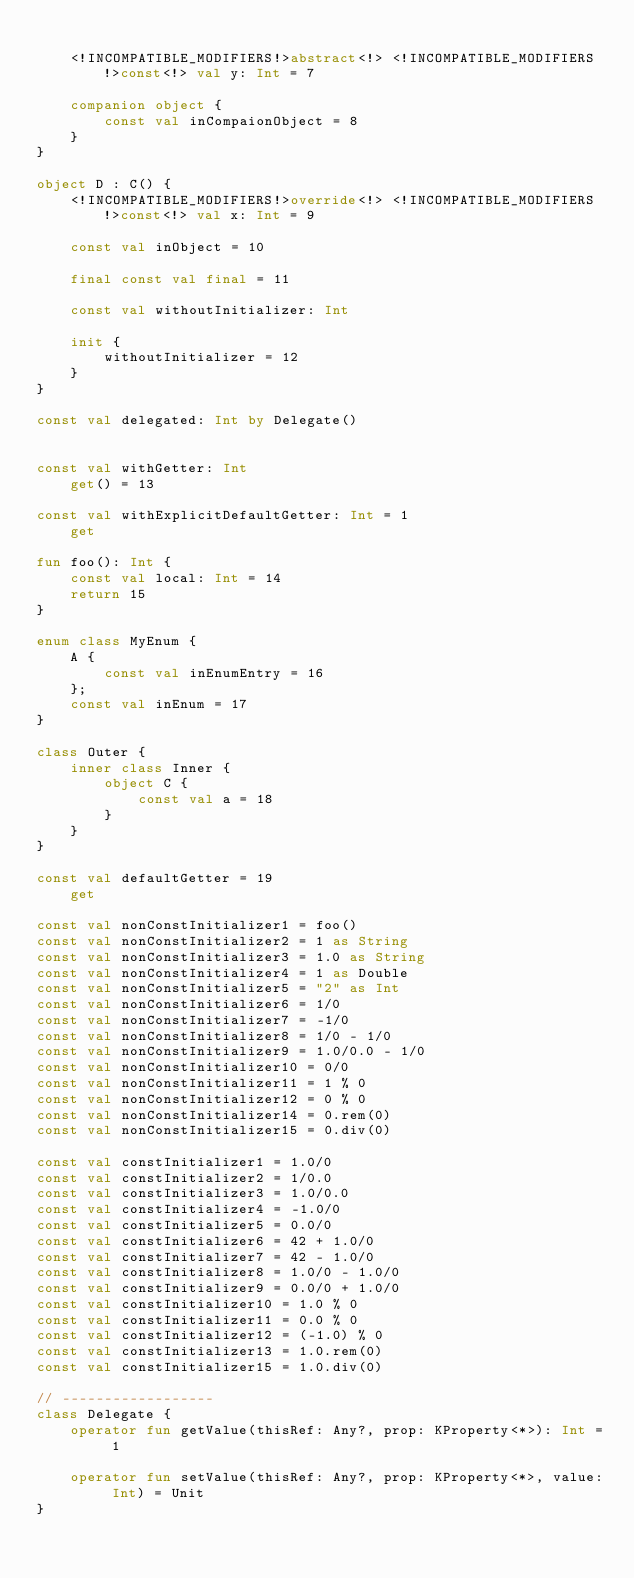<code> <loc_0><loc_0><loc_500><loc_500><_Kotlin_>
    <!INCOMPATIBLE_MODIFIERS!>abstract<!> <!INCOMPATIBLE_MODIFIERS!>const<!> val y: Int = 7

    companion object {
        const val inCompaionObject = 8
    }
}

object D : C() {
    <!INCOMPATIBLE_MODIFIERS!>override<!> <!INCOMPATIBLE_MODIFIERS!>const<!> val x: Int = 9

    const val inObject = 10

    final const val final = 11

    const val withoutInitializer: Int

    init {
        withoutInitializer = 12
    }
}

const val delegated: Int by Delegate()


const val withGetter: Int
    get() = 13

const val withExplicitDefaultGetter: Int = 1
    get

fun foo(): Int {
    const val local: Int = 14
    return 15
}

enum class MyEnum {
    A {
        const val inEnumEntry = 16
    };
    const val inEnum = 17
}

class Outer {
    inner class Inner {
        object C {
            const val a = 18
        }
    }
}

const val defaultGetter = 19
    get

const val nonConstInitializer1 = foo()
const val nonConstInitializer2 = 1 as String
const val nonConstInitializer3 = 1.0 as String
const val nonConstInitializer4 = 1 as Double
const val nonConstInitializer5 = "2" as Int
const val nonConstInitializer6 = 1/0
const val nonConstInitializer7 = -1/0
const val nonConstInitializer8 = 1/0 - 1/0
const val nonConstInitializer9 = 1.0/0.0 - 1/0
const val nonConstInitializer10 = 0/0
const val nonConstInitializer11 = 1 % 0
const val nonConstInitializer12 = 0 % 0
const val nonConstInitializer14 = 0.rem(0)
const val nonConstInitializer15 = 0.div(0)

const val constInitializer1 = 1.0/0
const val constInitializer2 = 1/0.0
const val constInitializer3 = 1.0/0.0
const val constInitializer4 = -1.0/0
const val constInitializer5 = 0.0/0
const val constInitializer6 = 42 + 1.0/0
const val constInitializer7 = 42 - 1.0/0
const val constInitializer8 = 1.0/0 - 1.0/0
const val constInitializer9 = 0.0/0 + 1.0/0
const val constInitializer10 = 1.0 % 0
const val constInitializer11 = 0.0 % 0
const val constInitializer12 = (-1.0) % 0
const val constInitializer13 = 1.0.rem(0)
const val constInitializer15 = 1.0.div(0)

// ------------------
class Delegate {
    operator fun getValue(thisRef: Any?, prop: KProperty<*>): Int = 1

    operator fun setValue(thisRef: Any?, prop: KProperty<*>, value: Int) = Unit
}
</code> 